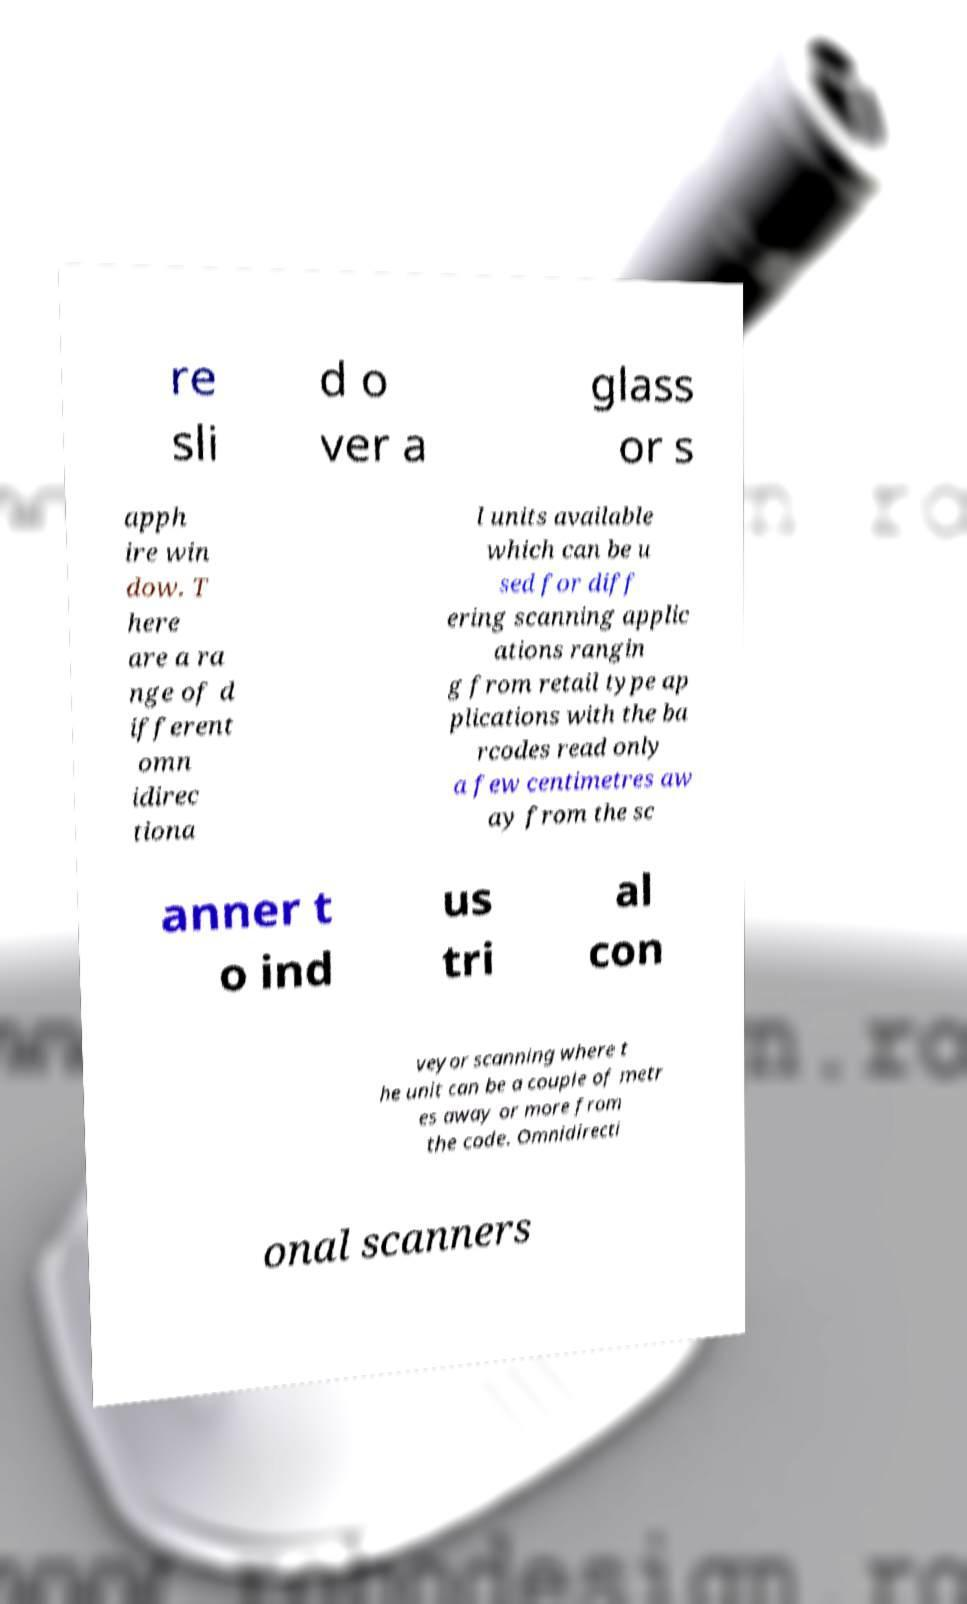Can you read and provide the text displayed in the image?This photo seems to have some interesting text. Can you extract and type it out for me? re sli d o ver a glass or s apph ire win dow. T here are a ra nge of d ifferent omn idirec tiona l units available which can be u sed for diff ering scanning applic ations rangin g from retail type ap plications with the ba rcodes read only a few centimetres aw ay from the sc anner t o ind us tri al con veyor scanning where t he unit can be a couple of metr es away or more from the code. Omnidirecti onal scanners 